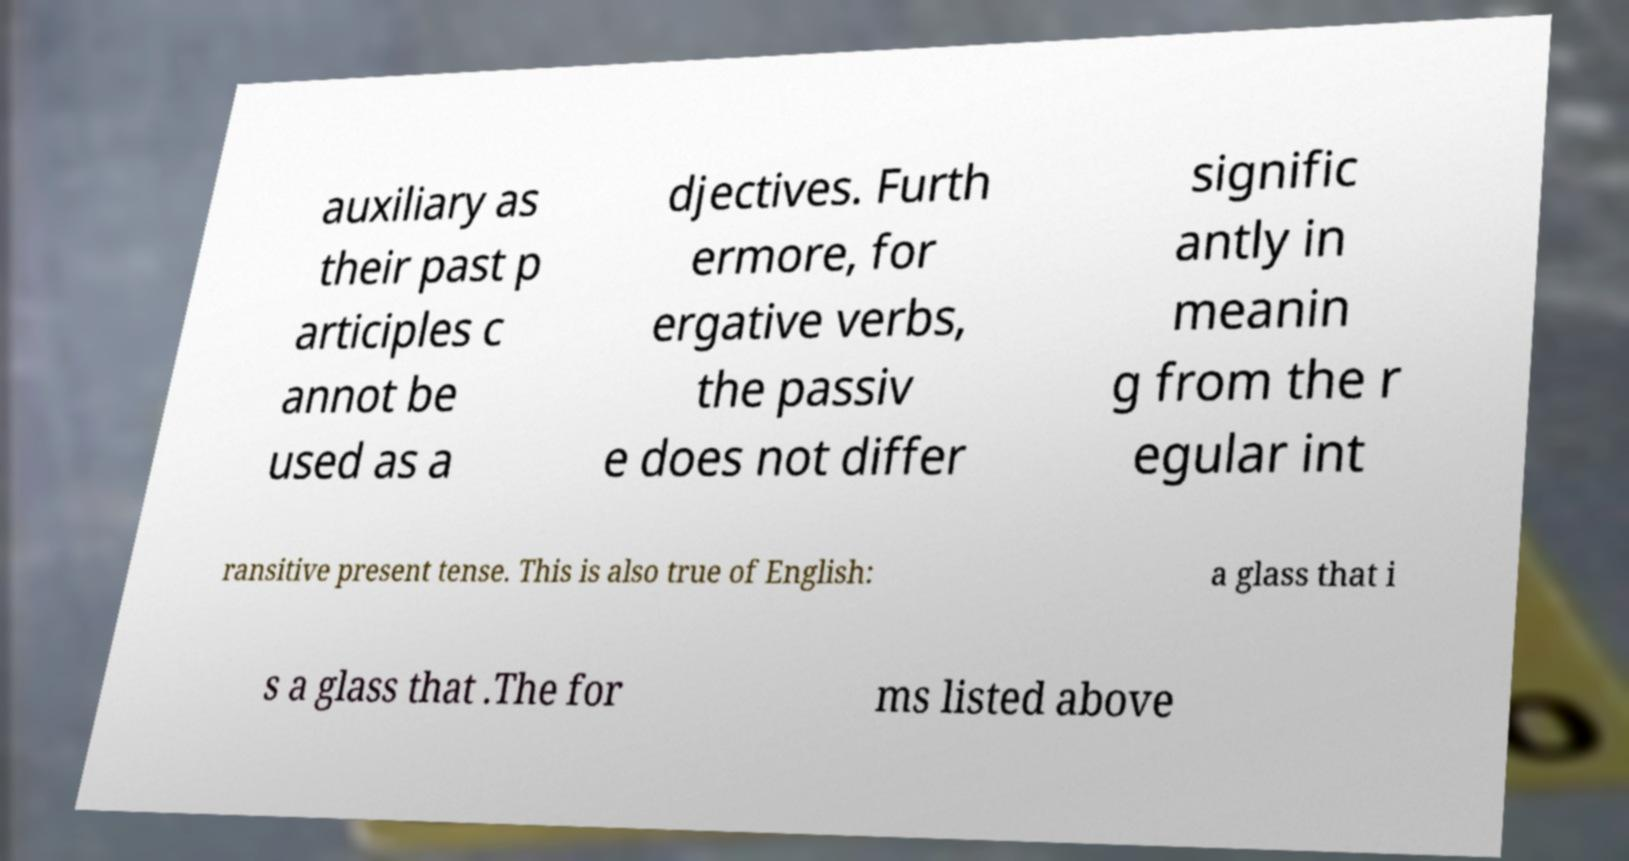Please read and relay the text visible in this image. What does it say? auxiliary as their past p articiples c annot be used as a djectives. Furth ermore, for ergative verbs, the passiv e does not differ signific antly in meanin g from the r egular int ransitive present tense. This is also true of English: a glass that i s a glass that .The for ms listed above 